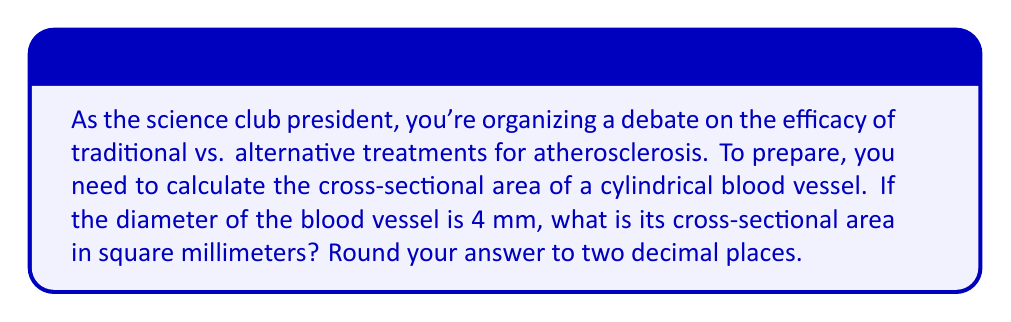Show me your answer to this math problem. To solve this problem, we need to follow these steps:

1) First, recall that the cross-section of a cylindrical blood vessel is a circle.

2) The formula for the area of a circle is:

   $$A = \pi r^2$$

   where $A$ is the area and $r$ is the radius.

3) We are given the diameter, which is 4 mm. The radius is half of the diameter:

   $$r = \frac{diameter}{2} = \frac{4}{2} = 2 \text{ mm}$$

4) Now we can substitute this into our area formula:

   $$A = \pi (2 \text{ mm})^2 = 4\pi \text{ mm}^2$$

5) Let's calculate this:

   $$A = 4 \times 3.14159... \text{ mm}^2 \approx 12.5664 \text{ mm}^2$$

6) Rounding to two decimal places:

   $$A \approx 12.57 \text{ mm}^2$$

This calculation is crucial in biomedical engineering for understanding blood flow and designing treatments for vascular diseases like atherosclerosis.

[asy]
import geometry;

size(100);
draw(circle((0,0),2));
draw((-2.5,0)--(2.5,0),arrow=Arrows(TeXHead));
draw((0,-2.5)--(0,2.5),arrow=Arrows(TeXHead));
label("4 mm", (2.5,0), E);
dot((0,0));
label("r = 2 mm", (1,1), NE);
[/asy]
Answer: $12.57 \text{ mm}^2$ 